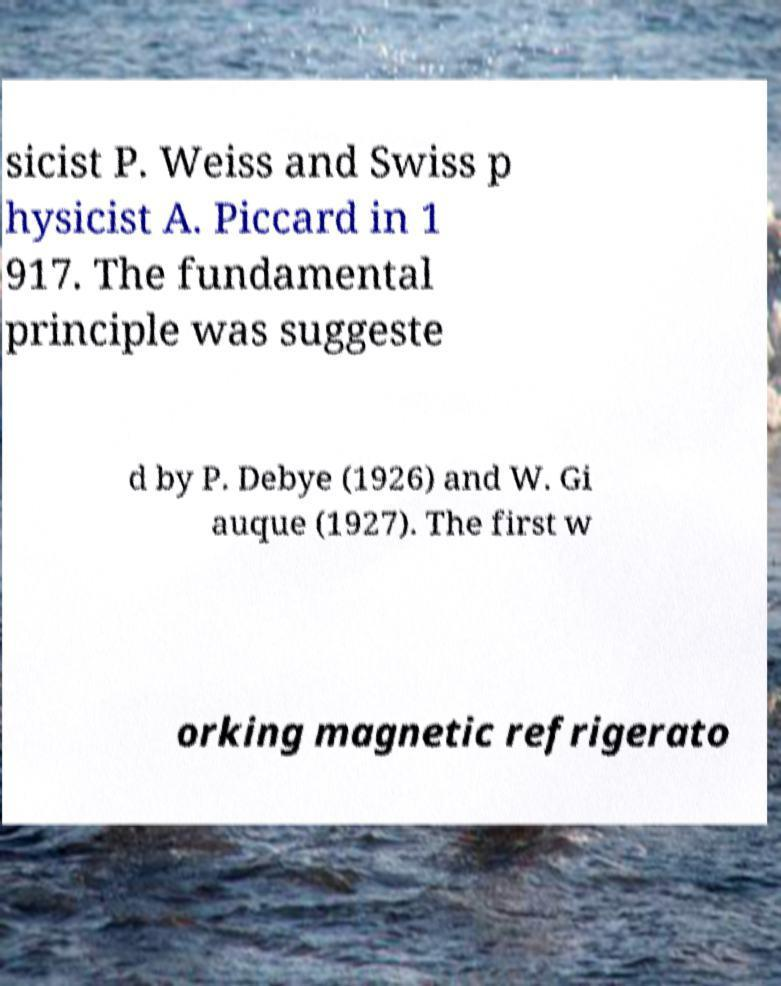There's text embedded in this image that I need extracted. Can you transcribe it verbatim? sicist P. Weiss and Swiss p hysicist A. Piccard in 1 917. The fundamental principle was suggeste d by P. Debye (1926) and W. Gi auque (1927). The first w orking magnetic refrigerato 